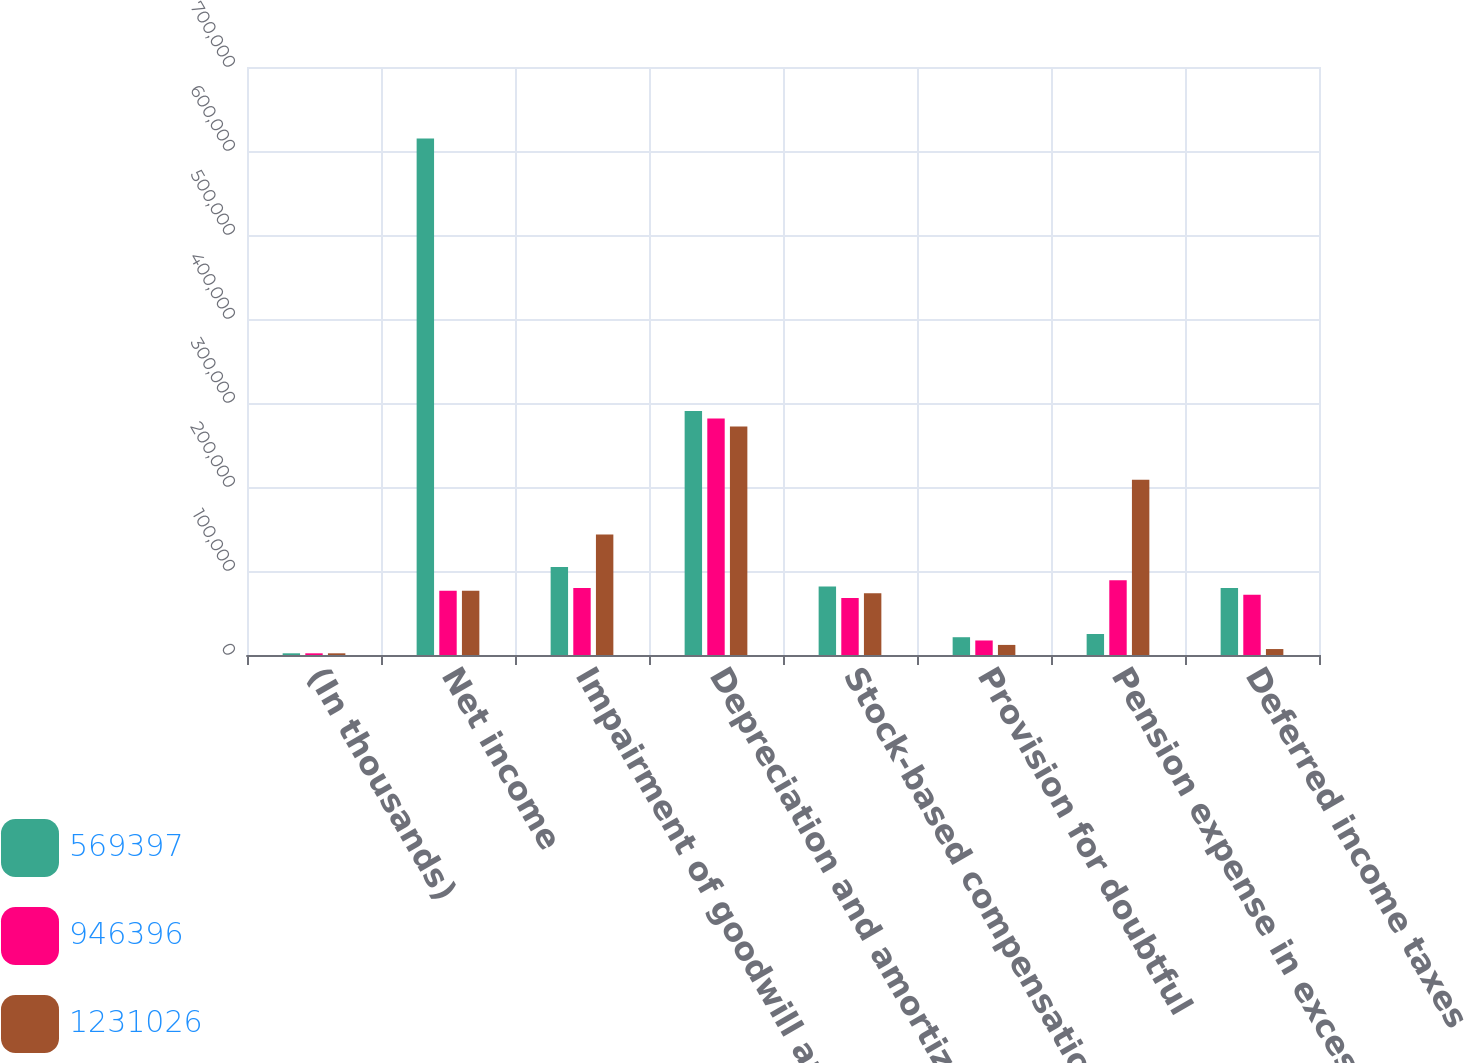Convert chart. <chart><loc_0><loc_0><loc_500><loc_500><stacked_bar_chart><ecel><fcel>(In thousands)<fcel>Net income<fcel>Impairment of goodwill and<fcel>Depreciation and amortization<fcel>Stock-based compensation<fcel>Provision for doubtful<fcel>Pension expense in excess of<fcel>Deferred income taxes<nl><fcel>569397<fcel>2017<fcel>614923<fcel>104651<fcel>290503<fcel>81641<fcel>21171<fcel>25022<fcel>79838<nl><fcel>946396<fcel>2016<fcel>76532<fcel>79644<fcel>281577<fcel>67762<fcel>17283<fcel>89005<fcel>71625<nl><fcel>1.23103e+06<fcel>2015<fcel>76532<fcel>143562<fcel>272075<fcel>73420<fcel>12006<fcel>208709<fcel>7088<nl></chart> 